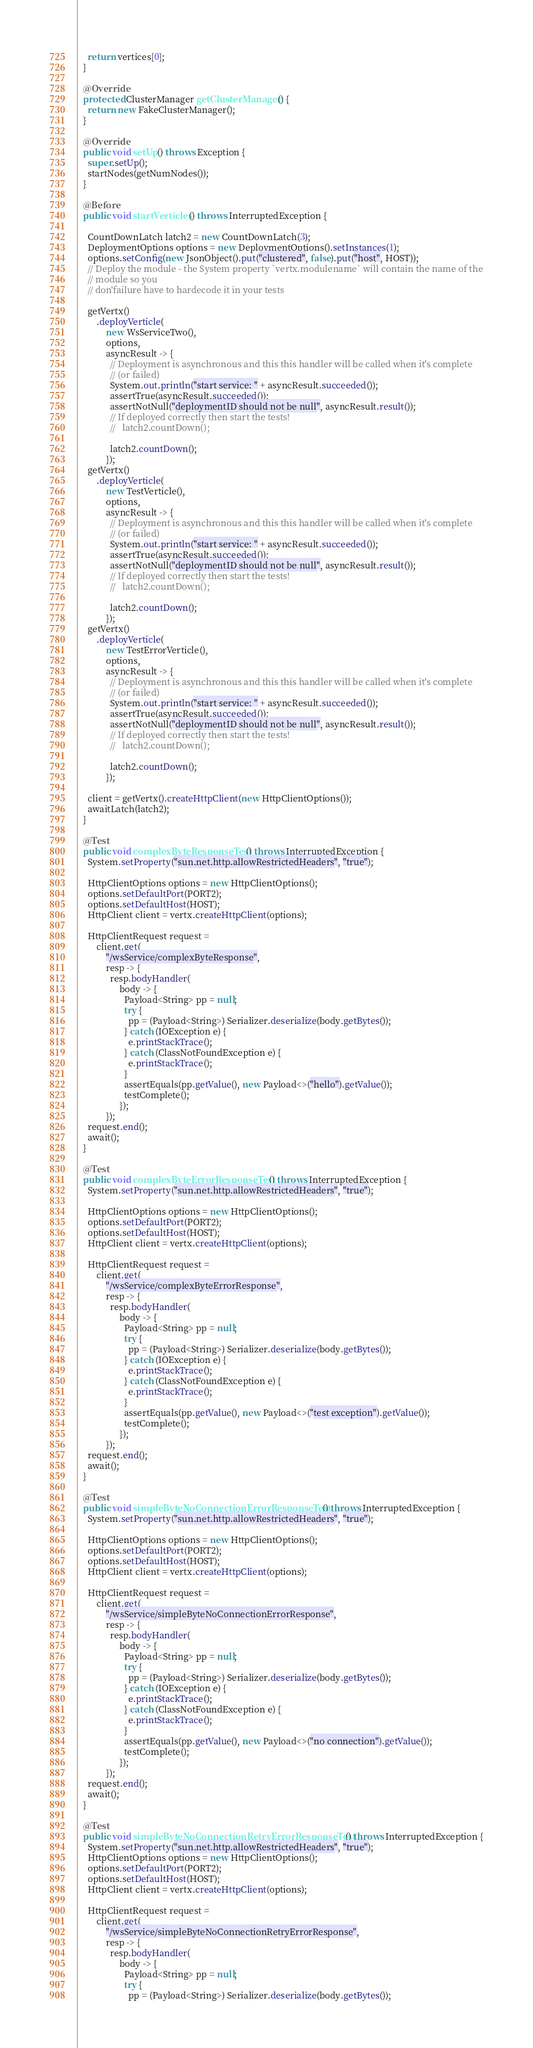<code> <loc_0><loc_0><loc_500><loc_500><_Java_>    return vertices[0];
  }

  @Override
  protected ClusterManager getClusterManager() {
    return new FakeClusterManager();
  }

  @Override
  public void setUp() throws Exception {
    super.setUp();
    startNodes(getNumNodes());
  }

  @Before
  public void startVerticles() throws InterruptedException {

    CountDownLatch latch2 = new CountDownLatch(3);
    DeploymentOptions options = new DeploymentOptions().setInstances(1);
    options.setConfig(new JsonObject().put("clustered", false).put("host", HOST));
    // Deploy the module - the System property `vertx.modulename` will contain the name of the
    // module so you
    // don'failure have to hardecode it in your tests

    getVertx()
        .deployVerticle(
            new WsServiceTwo(),
            options,
            asyncResult -> {
              // Deployment is asynchronous and this this handler will be called when it's complete
              // (or failed)
              System.out.println("start service: " + asyncResult.succeeded());
              assertTrue(asyncResult.succeeded());
              assertNotNull("deploymentID should not be null", asyncResult.result());
              // If deployed correctly then start the tests!
              //   latch2.countDown();

              latch2.countDown();
            });
    getVertx()
        .deployVerticle(
            new TestVerticle(),
            options,
            asyncResult -> {
              // Deployment is asynchronous and this this handler will be called when it's complete
              // (or failed)
              System.out.println("start service: " + asyncResult.succeeded());
              assertTrue(asyncResult.succeeded());
              assertNotNull("deploymentID should not be null", asyncResult.result());
              // If deployed correctly then start the tests!
              //   latch2.countDown();

              latch2.countDown();
            });
    getVertx()
        .deployVerticle(
            new TestErrorVerticle(),
            options,
            asyncResult -> {
              // Deployment is asynchronous and this this handler will be called when it's complete
              // (or failed)
              System.out.println("start service: " + asyncResult.succeeded());
              assertTrue(asyncResult.succeeded());
              assertNotNull("deploymentID should not be null", asyncResult.result());
              // If deployed correctly then start the tests!
              //   latch2.countDown();

              latch2.countDown();
            });

    client = getVertx().createHttpClient(new HttpClientOptions());
    awaitLatch(latch2);
  }

  @Test
  public void complexByteResponseTest() throws InterruptedException {
    System.setProperty("sun.net.http.allowRestrictedHeaders", "true");

    HttpClientOptions options = new HttpClientOptions();
    options.setDefaultPort(PORT2);
    options.setDefaultHost(HOST);
    HttpClient client = vertx.createHttpClient(options);

    HttpClientRequest request =
        client.get(
            "/wsService/complexByteResponse",
            resp -> {
              resp.bodyHandler(
                  body -> {
                    Payload<String> pp = null;
                    try {
                      pp = (Payload<String>) Serializer.deserialize(body.getBytes());
                    } catch (IOException e) {
                      e.printStackTrace();
                    } catch (ClassNotFoundException e) {
                      e.printStackTrace();
                    }
                    assertEquals(pp.getValue(), new Payload<>("hello").getValue());
                    testComplete();
                  });
            });
    request.end();
    await();
  }

  @Test
  public void complexByteErrorResponseTest() throws InterruptedException {
    System.setProperty("sun.net.http.allowRestrictedHeaders", "true");

    HttpClientOptions options = new HttpClientOptions();
    options.setDefaultPort(PORT2);
    options.setDefaultHost(HOST);
    HttpClient client = vertx.createHttpClient(options);

    HttpClientRequest request =
        client.get(
            "/wsService/complexByteErrorResponse",
            resp -> {
              resp.bodyHandler(
                  body -> {
                    Payload<String> pp = null;
                    try {
                      pp = (Payload<String>) Serializer.deserialize(body.getBytes());
                    } catch (IOException e) {
                      e.printStackTrace();
                    } catch (ClassNotFoundException e) {
                      e.printStackTrace();
                    }
                    assertEquals(pp.getValue(), new Payload<>("test exception").getValue());
                    testComplete();
                  });
            });
    request.end();
    await();
  }

  @Test
  public void simpleByteNoConnectionErrorResponseTest() throws InterruptedException {
    System.setProperty("sun.net.http.allowRestrictedHeaders", "true");

    HttpClientOptions options = new HttpClientOptions();
    options.setDefaultPort(PORT2);
    options.setDefaultHost(HOST);
    HttpClient client = vertx.createHttpClient(options);

    HttpClientRequest request =
        client.get(
            "/wsService/simpleByteNoConnectionErrorResponse",
            resp -> {
              resp.bodyHandler(
                  body -> {
                    Payload<String> pp = null;
                    try {
                      pp = (Payload<String>) Serializer.deserialize(body.getBytes());
                    } catch (IOException e) {
                      e.printStackTrace();
                    } catch (ClassNotFoundException e) {
                      e.printStackTrace();
                    }
                    assertEquals(pp.getValue(), new Payload<>("no connection").getValue());
                    testComplete();
                  });
            });
    request.end();
    await();
  }

  @Test
  public void simpleByteNoConnectionRetryErrorResponseTest() throws InterruptedException {
    System.setProperty("sun.net.http.allowRestrictedHeaders", "true");
    HttpClientOptions options = new HttpClientOptions();
    options.setDefaultPort(PORT2);
    options.setDefaultHost(HOST);
    HttpClient client = vertx.createHttpClient(options);

    HttpClientRequest request =
        client.get(
            "/wsService/simpleByteNoConnectionRetryErrorResponse",
            resp -> {
              resp.bodyHandler(
                  body -> {
                    Payload<String> pp = null;
                    try {
                      pp = (Payload<String>) Serializer.deserialize(body.getBytes());</code> 